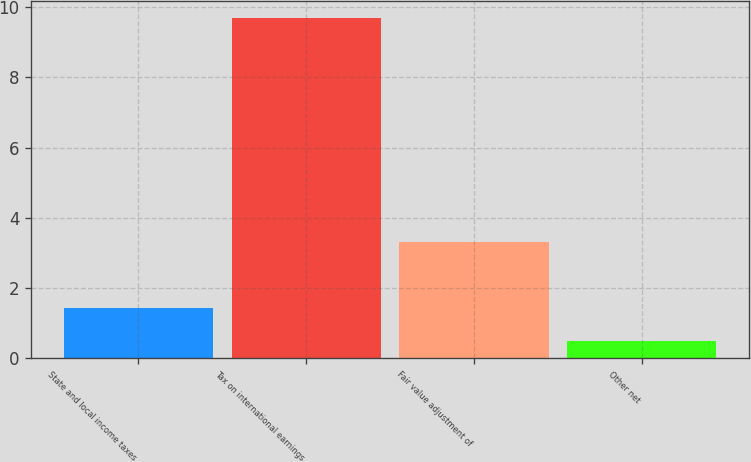Convert chart. <chart><loc_0><loc_0><loc_500><loc_500><bar_chart><fcel>State and local income taxes<fcel>Tax on international earnings<fcel>Fair value adjustment of<fcel>Other net<nl><fcel>1.42<fcel>9.7<fcel>3.3<fcel>0.5<nl></chart> 